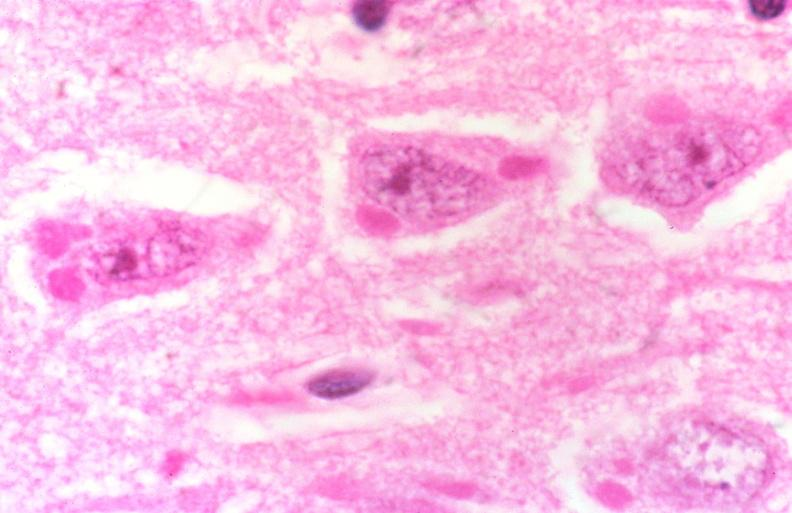does this image show rabies, negri bodies?
Answer the question using a single word or phrase. Yes 